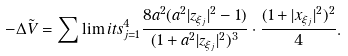<formula> <loc_0><loc_0><loc_500><loc_500>- \Delta \tilde { V } = \sum \lim i t s _ { j = 1 } ^ { 4 } \frac { 8 a ^ { 2 } ( a ^ { 2 } | z _ { \xi _ { j } } | ^ { 2 } - 1 ) } { ( 1 + a ^ { 2 } | z _ { \xi _ { j } } | ^ { 2 } ) ^ { 3 } } \cdot \frac { ( 1 + | x _ { \xi _ { j } } | ^ { 2 } ) ^ { 2 } } { 4 } .</formula> 